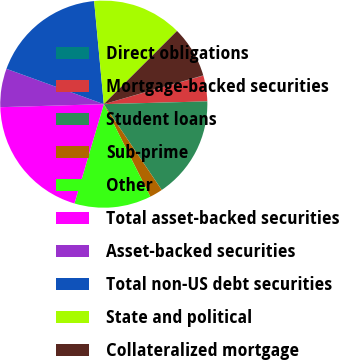Convert chart to OTSL. <chart><loc_0><loc_0><loc_500><loc_500><pie_chart><fcel>Direct obligations<fcel>Mortgage-backed securities<fcel>Student loans<fcel>Sub-prime<fcel>Other<fcel>Total asset-backed securities<fcel>Asset-backed securities<fcel>Total non-US debt securities<fcel>State and political<fcel>Collateralized mortgage<nl><fcel>0.04%<fcel>4.02%<fcel>15.98%<fcel>2.03%<fcel>11.99%<fcel>19.96%<fcel>6.01%<fcel>17.97%<fcel>13.99%<fcel>8.01%<nl></chart> 